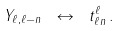<formula> <loc_0><loc_0><loc_500><loc_500>Y _ { \ell , \ell - n } \ \leftrightarrow \ t _ { \ell n } ^ { \ell } \, .</formula> 